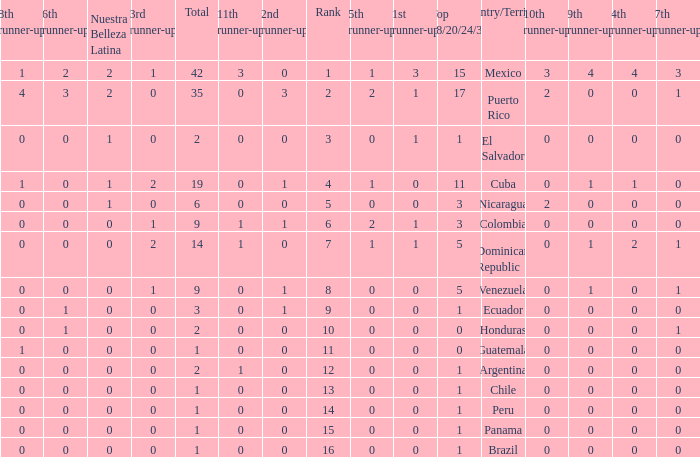What is the 3rd runner-up of the country with more than 0 9th runner-up, an 11th runner-up of 0, and the 1st runner-up greater than 0? None. 